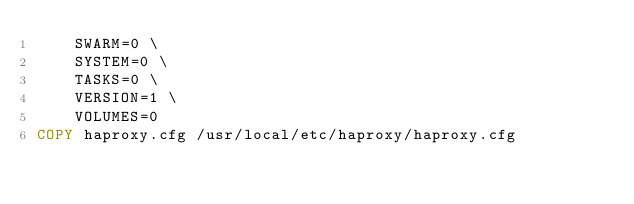<code> <loc_0><loc_0><loc_500><loc_500><_Dockerfile_>    SWARM=0 \
    SYSTEM=0 \
    TASKS=0 \
    VERSION=1 \
    VOLUMES=0
COPY haproxy.cfg /usr/local/etc/haproxy/haproxy.cfg
</code> 